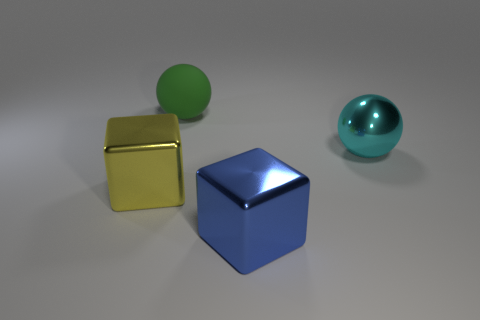Add 1 large blue spheres. How many objects exist? 5 Add 2 cyan balls. How many cyan balls exist? 3 Subtract 0 blue spheres. How many objects are left? 4 Subtract all rubber balls. Subtract all yellow blocks. How many objects are left? 2 Add 4 large cyan metal things. How many large cyan metal things are left? 5 